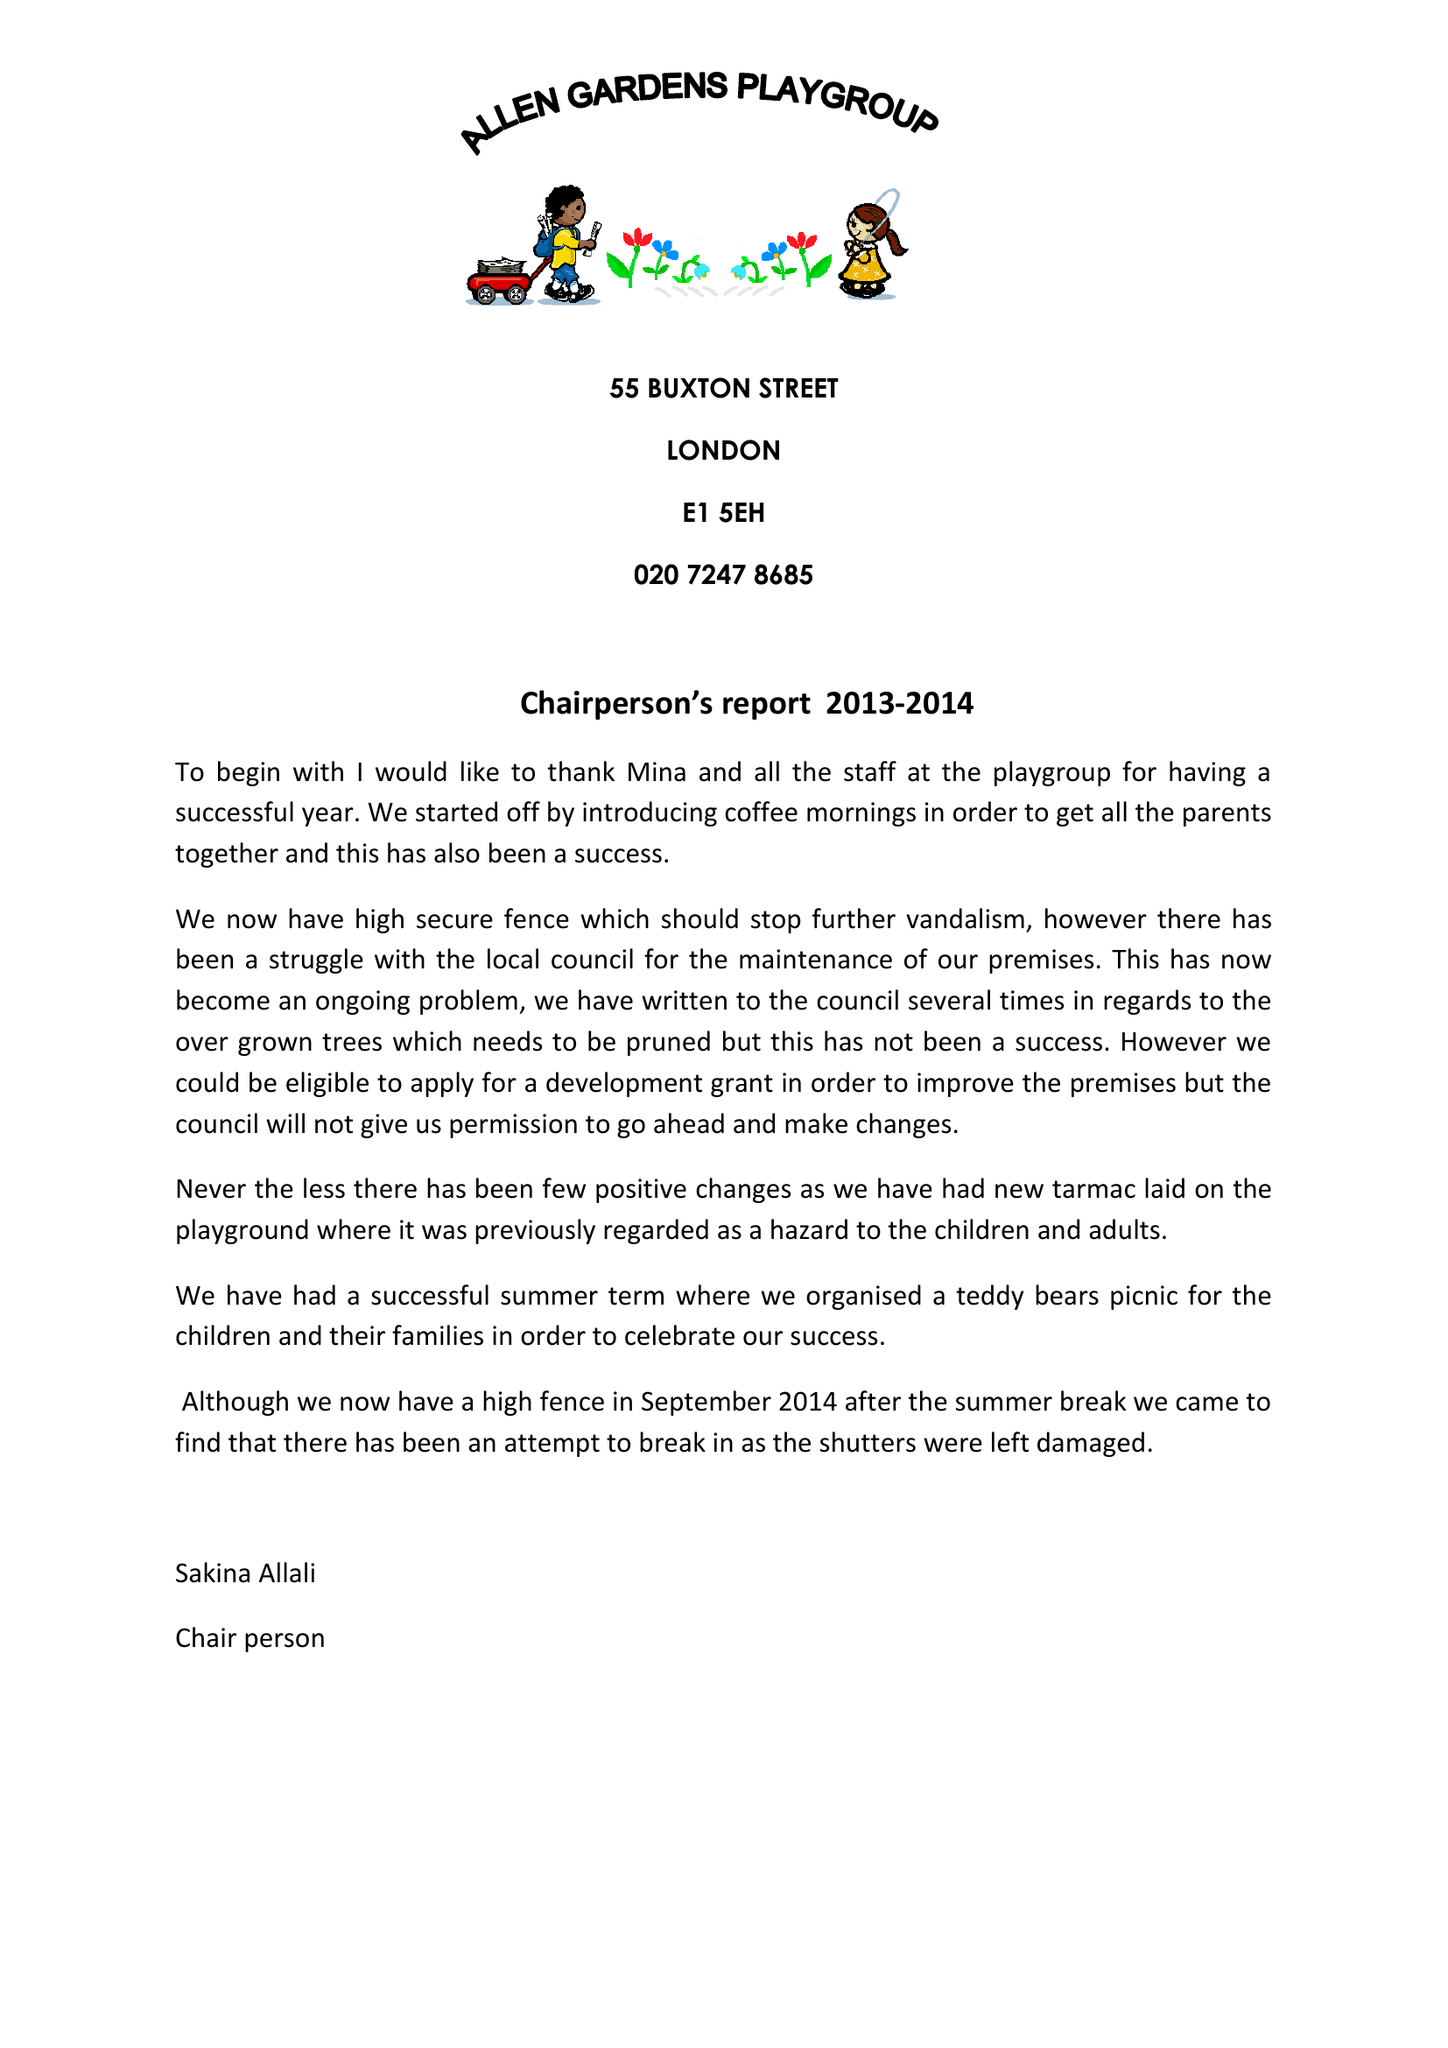What is the value for the charity_name?
Answer the question using a single word or phrase. Allen Gardens Playgroup 